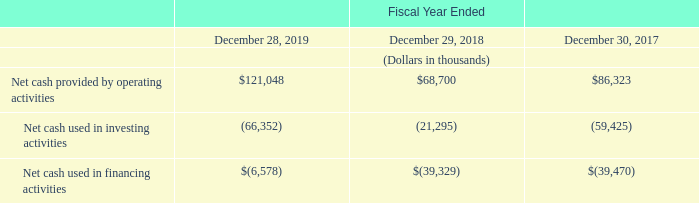Operating Activities
Net cash provided by operating activities in fiscal 2019 was primarily attributable to net income of $39.3 million, which included $89.9 million of net non-cash items, offset by changes in operating assets and liabilities using $8.2 million of cash as discussed in more detail below. Accounts receivable increased $2.6 million to $97.9 million at December 28, 2019 compared to $95.3 million at December 29, 2018 as a result of strong collections despite increased revenues and changes in payment terms related to customer mix.
Inventories, net, increased $5.6 million to $83.3 million at December 28, 2019 compared to $77.7 million at December 29, 2018 as a result of higher sales volumes, partially offset by a $10.4 million increase to our provision for excess and obsolete inventories. Accrued liabilities increased $8.7 million to $36.4 million at December 28, 2019 compared to $27.7 million at December 29, 2018, as a result of an increase in employee performance-based compensation and benefits and an increase in accrued income taxes due to timing of payments.
Accounts payable increased $0.9 million to $40.9 million at December 28, 2019 compared to $40.0 million at December 29, 2018, as a result of higher volumes mostly offset by the impact of timing of vendor payments.
Investing Activities
Net cash used in investing activities in fiscal 2019 primarily related to $20.8 million of cash used in the acquisition of property, plant and equipment, $20.5 million paid (net of cash acquired) as part of the consideration for the acquisition of FRT, and $25.1 million used for the purchase of marketable securities, net of maturities.
Financing Activities
Net cash used in financing activities in fiscal 2019 primarily related to $30.0 million of principal payments made towards the repayment of our term loan and $8.0 million related to tax withholdings associated with the net share settlements of our equity awards, largely offset by $23.4 million of proceeds from a term loan to fund the acquisition of FRT and $8.1 million of proceeds received from issuances of common stock under our stock incentive plans.
What is the increase in accounts payable from December 28, 2019 to December 29, 2018? $0.9 million. What is the change in Net cash provided by operating activities from Fiscal Year Ended December 28, 2019 to December 29, 2018?
Answer scale should be: thousand. 121,048-68,700
Answer: 52348. What is the change in Net cash used in investing activities from Fiscal Year Ended December 28, 2019 to December 29, 2018?
Answer scale should be: thousand. -66,352-(21,295)
Answer: -45057. In which year was Net cash provided by operating activities less than 100,000 thousands? Locate and analyze net cash provided by operating activities in row 4
answer: 2018, 2017. What was the net income in 2019? $39.3 million. What was the Net cash used in investing activities in 2019, 2018 and 2017 respectively?
Answer scale should be: thousand. (66,352), (21,295), (59,425). 